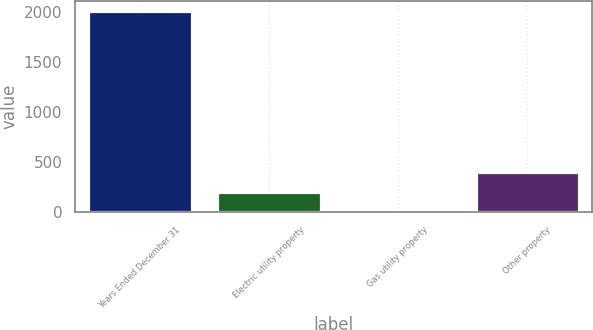Convert chart to OTSL. <chart><loc_0><loc_0><loc_500><loc_500><bar_chart><fcel>Years Ended December 31<fcel>Electric utility property<fcel>Gas utility property<fcel>Other property<nl><fcel>2017<fcel>204.31<fcel>2.9<fcel>405.72<nl></chart> 